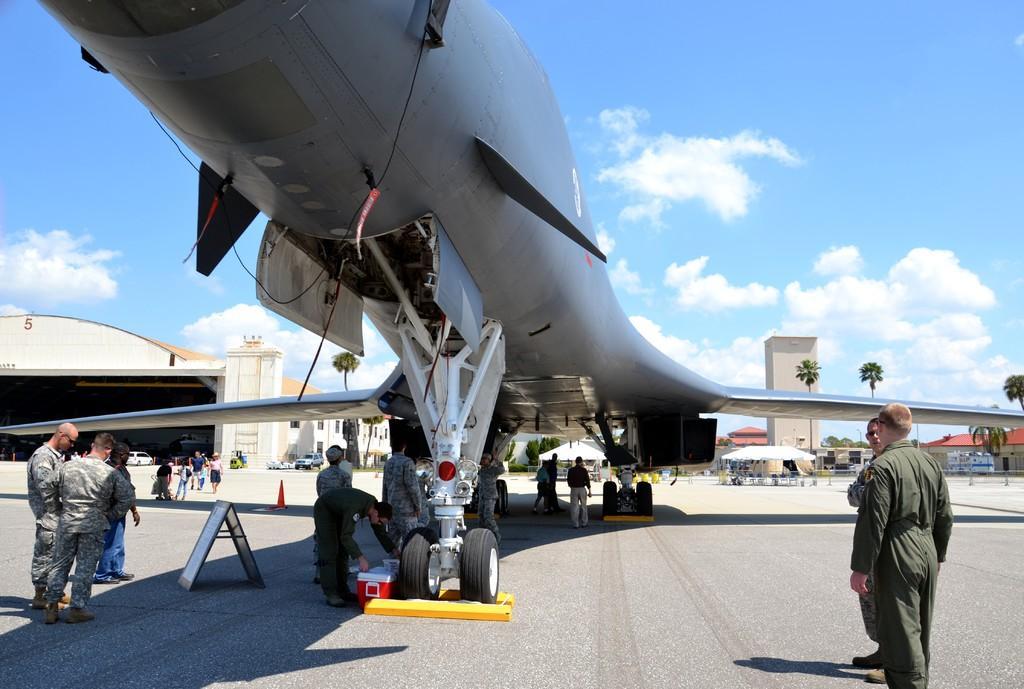In one or two sentences, can you explain what this image depicts? In this picture we can see an aircraft on the path. There is a box, board and a traffic cone on the path. Few people are visible on the path. We can see a tent. There are a few vehicles on the left side. Sky is blue in color and cloudy. 